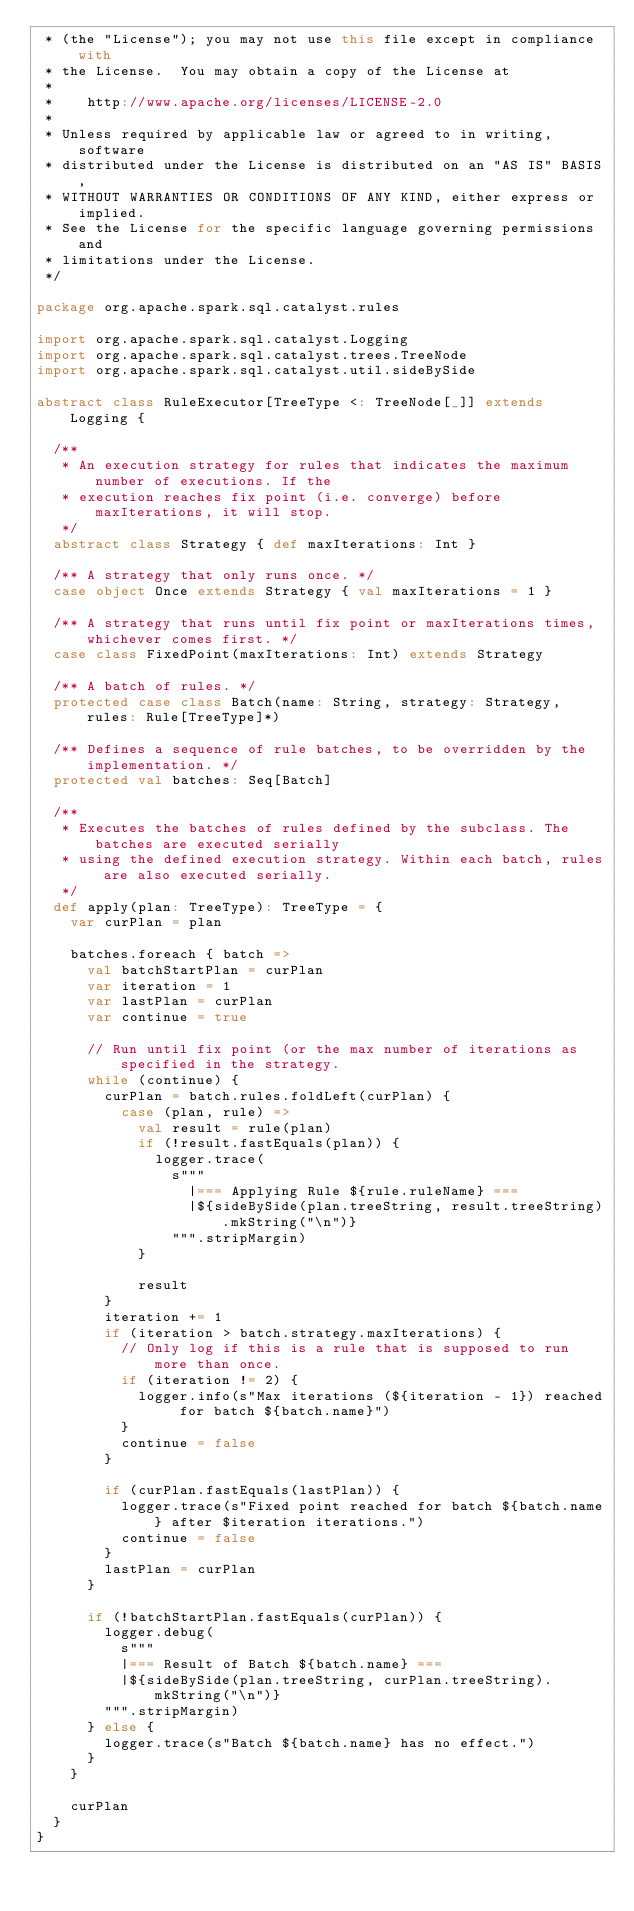<code> <loc_0><loc_0><loc_500><loc_500><_Scala_> * (the "License"); you may not use this file except in compliance with
 * the License.  You may obtain a copy of the License at
 *
 *    http://www.apache.org/licenses/LICENSE-2.0
 *
 * Unless required by applicable law or agreed to in writing, software
 * distributed under the License is distributed on an "AS IS" BASIS,
 * WITHOUT WARRANTIES OR CONDITIONS OF ANY KIND, either express or implied.
 * See the License for the specific language governing permissions and
 * limitations under the License.
 */

package org.apache.spark.sql.catalyst.rules

import org.apache.spark.sql.catalyst.Logging
import org.apache.spark.sql.catalyst.trees.TreeNode
import org.apache.spark.sql.catalyst.util.sideBySide

abstract class RuleExecutor[TreeType <: TreeNode[_]] extends Logging {

  /**
   * An execution strategy for rules that indicates the maximum number of executions. If the
   * execution reaches fix point (i.e. converge) before maxIterations, it will stop.
   */
  abstract class Strategy { def maxIterations: Int }

  /** A strategy that only runs once. */
  case object Once extends Strategy { val maxIterations = 1 }

  /** A strategy that runs until fix point or maxIterations times, whichever comes first. */
  case class FixedPoint(maxIterations: Int) extends Strategy

  /** A batch of rules. */
  protected case class Batch(name: String, strategy: Strategy, rules: Rule[TreeType]*)

  /** Defines a sequence of rule batches, to be overridden by the implementation. */
  protected val batches: Seq[Batch]

  /**
   * Executes the batches of rules defined by the subclass. The batches are executed serially
   * using the defined execution strategy. Within each batch, rules are also executed serially.
   */
  def apply(plan: TreeType): TreeType = {
    var curPlan = plan

    batches.foreach { batch =>
      val batchStartPlan = curPlan
      var iteration = 1
      var lastPlan = curPlan
      var continue = true

      // Run until fix point (or the max number of iterations as specified in the strategy.
      while (continue) {
        curPlan = batch.rules.foldLeft(curPlan) {
          case (plan, rule) =>
            val result = rule(plan)
            if (!result.fastEquals(plan)) {
              logger.trace(
                s"""
                  |=== Applying Rule ${rule.ruleName} ===
                  |${sideBySide(plan.treeString, result.treeString).mkString("\n")}
                """.stripMargin)
            }

            result
        }
        iteration += 1
        if (iteration > batch.strategy.maxIterations) {
          // Only log if this is a rule that is supposed to run more than once.
          if (iteration != 2) {
            logger.info(s"Max iterations (${iteration - 1}) reached for batch ${batch.name}")
          }
          continue = false
        }

        if (curPlan.fastEquals(lastPlan)) {
          logger.trace(s"Fixed point reached for batch ${batch.name} after $iteration iterations.")
          continue = false
        }
        lastPlan = curPlan
      }

      if (!batchStartPlan.fastEquals(curPlan)) {
        logger.debug(
          s"""
          |=== Result of Batch ${batch.name} ===
          |${sideBySide(plan.treeString, curPlan.treeString).mkString("\n")}
        """.stripMargin)
      } else {
        logger.trace(s"Batch ${batch.name} has no effect.")
      }
    }

    curPlan
  }
}
</code> 